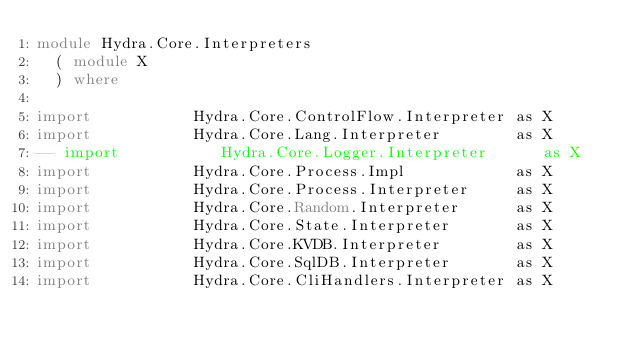Convert code to text. <code><loc_0><loc_0><loc_500><loc_500><_Haskell_>module Hydra.Core.Interpreters
  ( module X
  ) where

import           Hydra.Core.ControlFlow.Interpreter as X
import           Hydra.Core.Lang.Interpreter        as X
-- import           Hydra.Core.Logger.Interpreter      as X
import           Hydra.Core.Process.Impl            as X
import           Hydra.Core.Process.Interpreter     as X
import           Hydra.Core.Random.Interpreter      as X
import           Hydra.Core.State.Interpreter       as X
import           Hydra.Core.KVDB.Interpreter        as X
import           Hydra.Core.SqlDB.Interpreter       as X
import           Hydra.Core.CliHandlers.Interpreter as X
</code> 